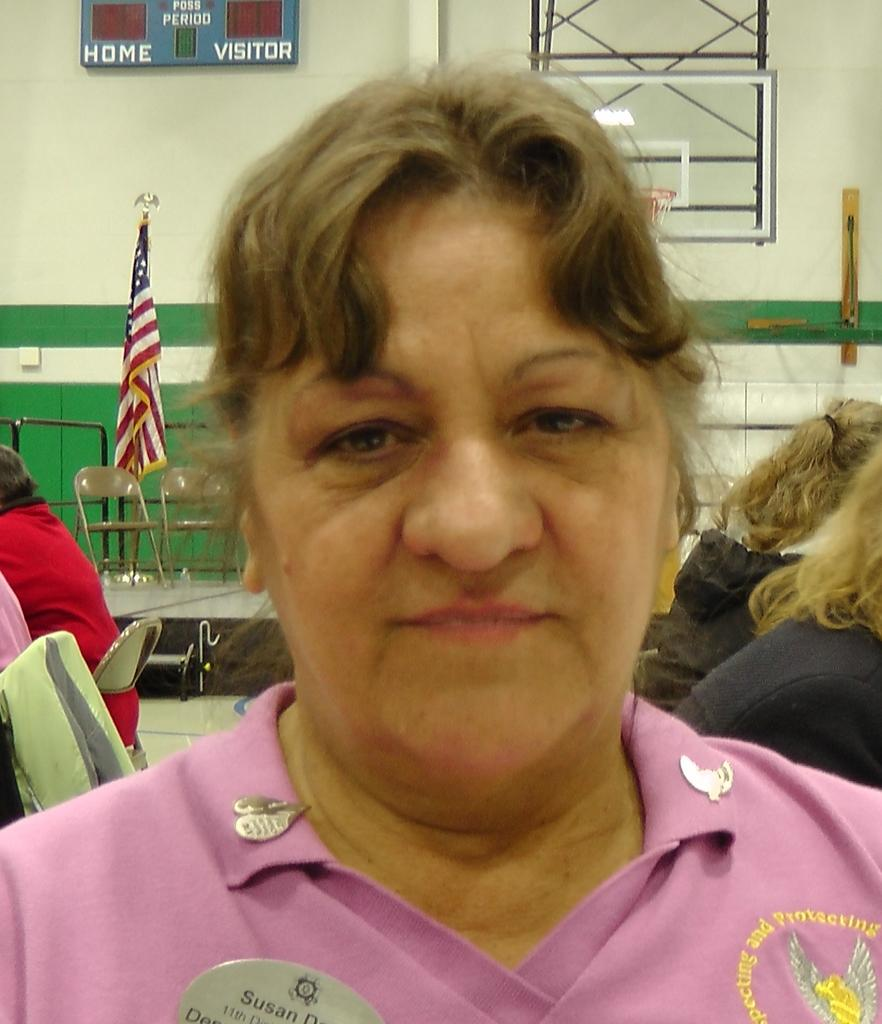Who is the main subject in the image? There is a woman in the image. What is the woman wearing? The woman is wearing a pink shirt. What can be seen behind the woman? There is a flag behind the woman. Are there any other people in the image? Yes, there are people sitting on chairs behind the woman. How many books are stacked on the channel in the image? There are no books or channels present in the image. 